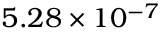<formula> <loc_0><loc_0><loc_500><loc_500>5 . 2 8 \times 1 0 ^ { - 7 }</formula> 